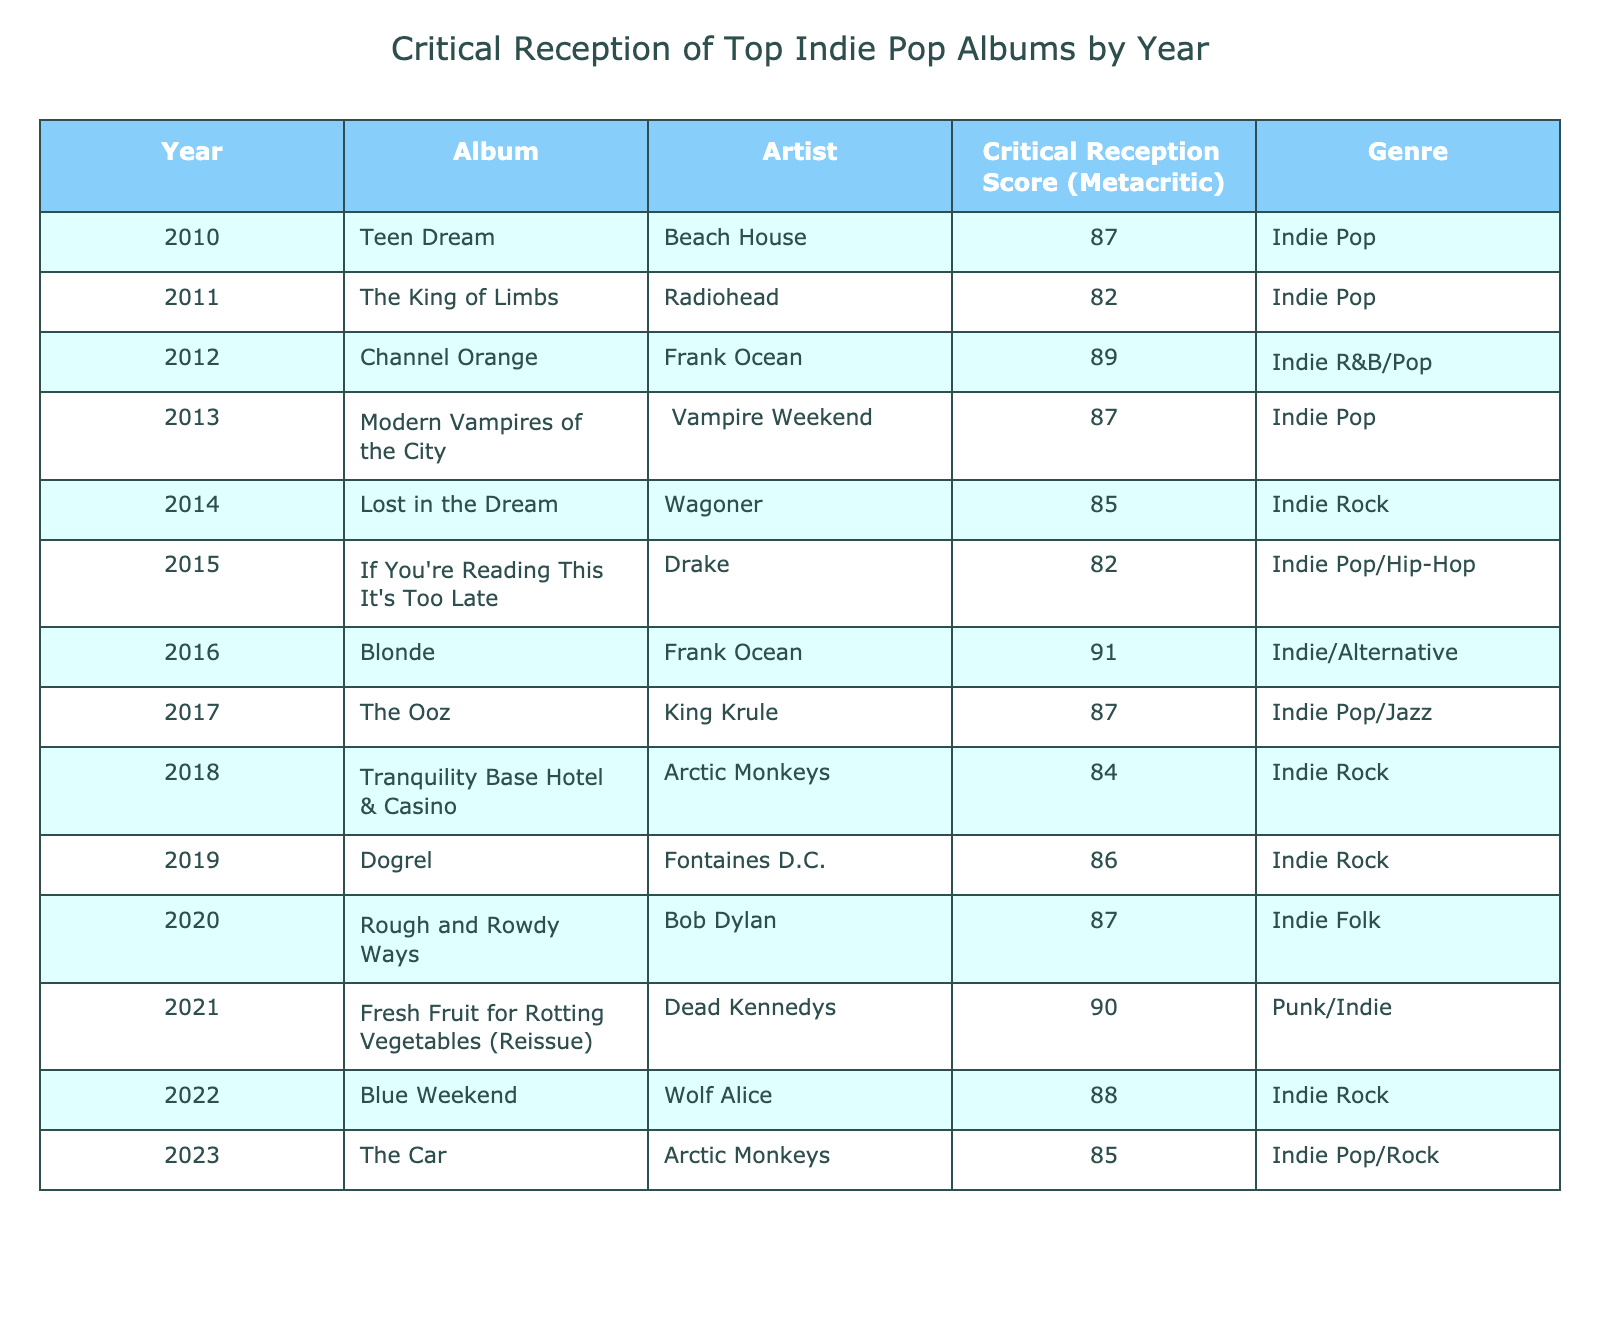What is the highest critical reception score listed in the table? The highest score in the table is found by looking through the "Critical Reception Score (Metacritic)" column. The maximum value appears to be 91, from the album "Blonde" by Frank Ocean in 2016.
Answer: 91 Which album released in 2013 has a critical reception score of 87? To find this, I refer to the table and look for the year 2013 with a critical score of 87, and the album listed is "Modern Vampires of the City" by Vampire Weekend.
Answer: Modern Vampires of the City What is the average critical reception score for albums listed from 2010 to 2013? The scores for the years 2010 to 2013 are: 87 (Teen Dream), 82 (The King of Limbs), 89 (Channel Orange), and 87 (Modern Vampires of the City). Summing these scores gives 87 + 82 + 89 + 87 = 345, and dividing by the number of albums (4) results in an average of 345 / 4 = 86.25.
Answer: 86.25 Did any album released in 2018 have a critical reception score above 85? Checking the year 2018 in the table, the album "Tranquility Base Hotel & Casino" has a score of 84. Since 84 is not above 85, the answer is no.
Answer: No How many albums released after 2015 had a critical reception score of 85 or higher? Reviewing the albums from 2016 onward, I find: "Blonde" (91), "The Ooz" (87), "Dogrel" (86), and "Blue Weekend" (88). The total count of these albums is 4.
Answer: 4 What is the difference between the highest and lowest critical reception scores in the table? The highest score is 91 (from "Blonde") and the lowest score is 82 (from "The King of Limbs" and "If You're Reading This It's Too Late"). Therefore, the difference is 91 - 82 = 9.
Answer: 9 Which artist has the most albums listed in the table? Analyzing the table, I see that Arctic Monkeys has 2 albums: "Tranquility Base Hotel & Casino" in 2018 and "The Car" in 2023, while no other artist has more than one album listed.
Answer: Arctic Monkeys Is there a trend in critical reception scores from 2016 to 2023? Noticing the scores: 91 (Blonde), 87 (The Ooz), 84 (Tranquility Base Hotel & Casino), 86 (Dogrel), 90 (Fresh Fruit for Rotting Vegetables), 88 (Blue Weekend), 85 (The Car). The scores mostly fluctuate without a clear upward or downward trend, suggesting variability rather than a distinct trend.
Answer: No clear trend What genre is most represented among the highest rated albums in the table? Examining the albums with scores of 87 or above, I find "Teen Dream", "Channel Orange", "Modern Vampires of the City", "Blonde", "The Ooz", "Dogrel", "Fresh Fruit for Rotting Vegetables", and "Blue Weekend". Counting the genre instances, it appears that "Indie Pop" appears 5 times among the highest scores.
Answer: Indie Pop 